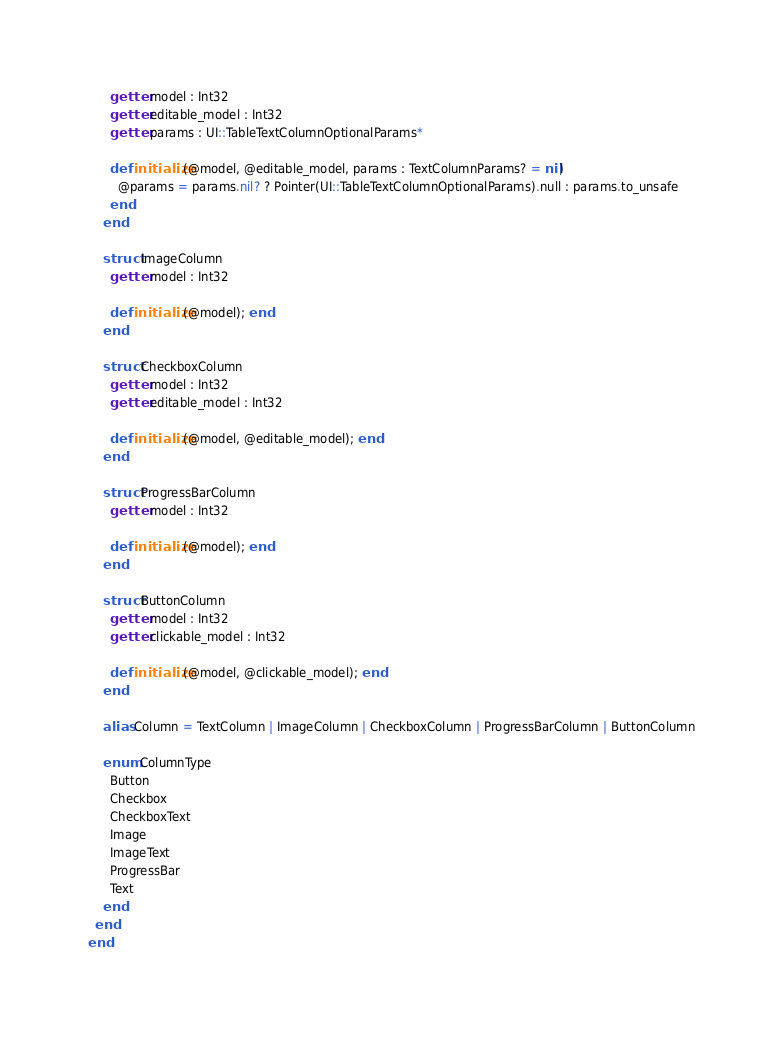Convert code to text. <code><loc_0><loc_0><loc_500><loc_500><_Crystal_>      getter model : Int32
      getter editable_model : Int32
      getter params : UI::TableTextColumnOptionalParams*

      def initialize(@model, @editable_model, params : TextColumnParams? = nil)
        @params = params.nil? ? Pointer(UI::TableTextColumnOptionalParams).null : params.to_unsafe
      end
    end

    struct ImageColumn
      getter model : Int32

      def initialize(@model); end
    end

    struct CheckboxColumn
      getter model : Int32
      getter editable_model : Int32

      def initialize(@model, @editable_model); end
    end

    struct ProgressBarColumn
      getter model : Int32

      def initialize(@model); end
    end

    struct ButtonColumn
      getter model : Int32
      getter clickable_model : Int32

      def initialize(@model, @clickable_model); end
    end

    alias Column = TextColumn | ImageColumn | CheckboxColumn | ProgressBarColumn | ButtonColumn

    enum ColumnType
      Button
      Checkbox
      CheckboxText
      Image
      ImageText
      ProgressBar
      Text
    end
  end
end</code> 